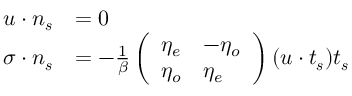<formula> <loc_0><loc_0><loc_500><loc_500>\begin{array} { r l } { u \cdot n _ { s } } & { = 0 } \\ { \sigma \cdot n _ { s } } & { = - \frac { 1 } { \beta } \left ( \begin{array} { l l } { \eta _ { e } } & { - \eta _ { o } } \\ { \eta _ { o } } & { \eta _ { e } } \end{array} \right ) ( u \cdot t _ { s } ) t _ { s } } \end{array}</formula> 